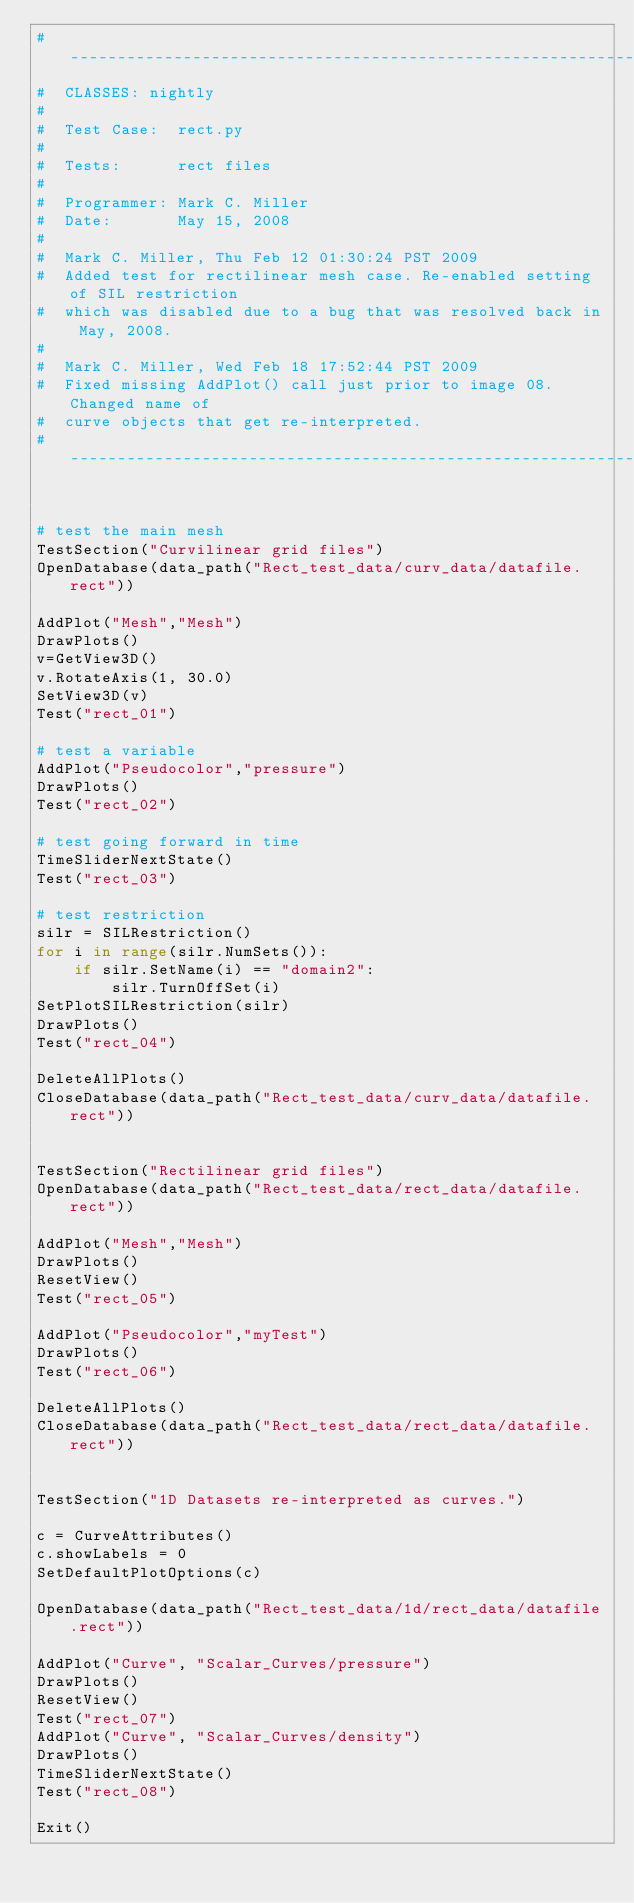<code> <loc_0><loc_0><loc_500><loc_500><_Python_># ----------------------------------------------------------------------------
#  CLASSES: nightly
#
#  Test Case:  rect.py 
#
#  Tests:      rect files 
#
#  Programmer: Mark C. Miller 
#  Date:       May 15, 2008 
#
#  Mark C. Miller, Thu Feb 12 01:30:24 PST 2009
#  Added test for rectilinear mesh case. Re-enabled setting of SIL restriction
#  which was disabled due to a bug that was resolved back in May, 2008.
#
#  Mark C. Miller, Wed Feb 18 17:52:44 PST 2009
#  Fixed missing AddPlot() call just prior to image 08. Changed name of 
#  curve objects that get re-interpreted.
# ----------------------------------------------------------------------------


# test the main mesh
TestSection("Curvilinear grid files")
OpenDatabase(data_path("Rect_test_data/curv_data/datafile.rect"))

AddPlot("Mesh","Mesh")
DrawPlots()
v=GetView3D()
v.RotateAxis(1, 30.0)
SetView3D(v)
Test("rect_01")

# test a variable
AddPlot("Pseudocolor","pressure")
DrawPlots()
Test("rect_02")

# test going forward in time
TimeSliderNextState()
Test("rect_03")

# test restriction
silr = SILRestriction()
for i in range(silr.NumSets()):
    if silr.SetName(i) == "domain2":
        silr.TurnOffSet(i)
SetPlotSILRestriction(silr)
DrawPlots()
Test("rect_04")

DeleteAllPlots()
CloseDatabase(data_path("Rect_test_data/curv_data/datafile.rect"))


TestSection("Rectilinear grid files")
OpenDatabase(data_path("Rect_test_data/rect_data/datafile.rect"))

AddPlot("Mesh","Mesh")
DrawPlots()
ResetView()
Test("rect_05")

AddPlot("Pseudocolor","myTest")
DrawPlots()
Test("rect_06")

DeleteAllPlots()
CloseDatabase(data_path("Rect_test_data/rect_data/datafile.rect"))


TestSection("1D Datasets re-interpreted as curves.")

c = CurveAttributes()
c.showLabels = 0
SetDefaultPlotOptions(c)

OpenDatabase(data_path("Rect_test_data/1d/rect_data/datafile.rect"))

AddPlot("Curve", "Scalar_Curves/pressure")
DrawPlots()
ResetView()
Test("rect_07")
AddPlot("Curve", "Scalar_Curves/density")
DrawPlots()
TimeSliderNextState()
Test("rect_08")

Exit()
</code> 